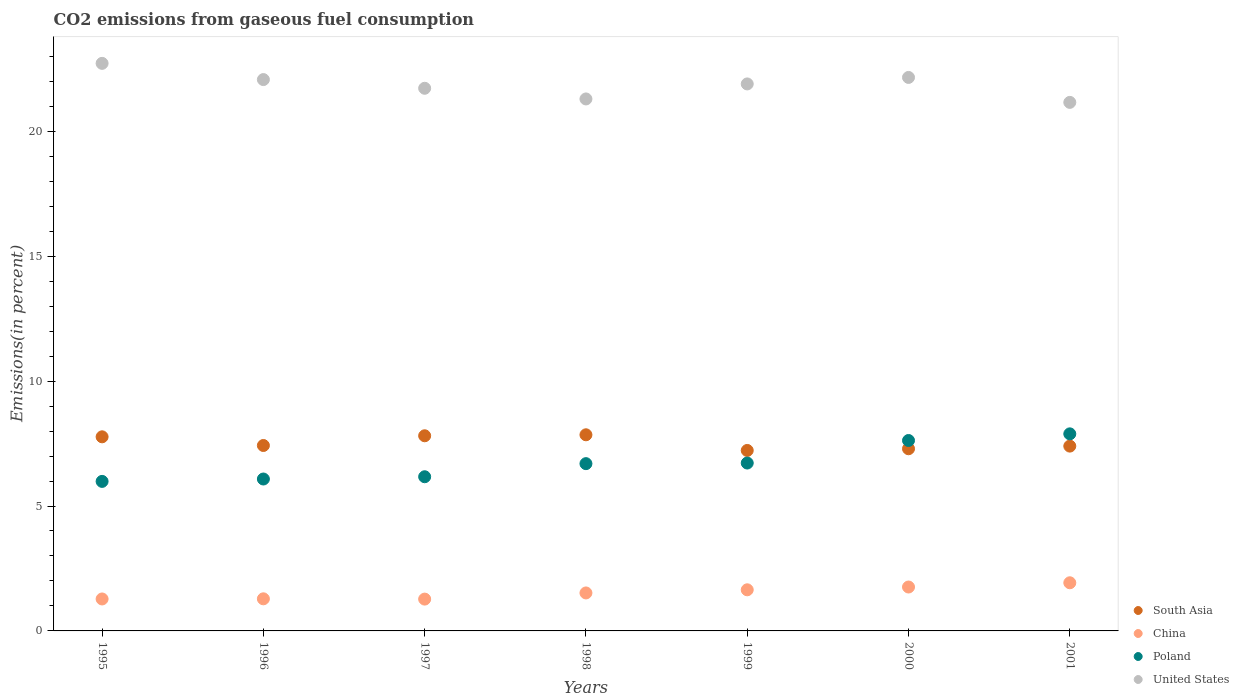How many different coloured dotlines are there?
Ensure brevity in your answer.  4. Is the number of dotlines equal to the number of legend labels?
Give a very brief answer. Yes. What is the total CO2 emitted in China in 1995?
Make the answer very short. 1.28. Across all years, what is the maximum total CO2 emitted in United States?
Give a very brief answer. 22.72. Across all years, what is the minimum total CO2 emitted in United States?
Ensure brevity in your answer.  21.16. What is the total total CO2 emitted in United States in the graph?
Your response must be concise. 153.01. What is the difference between the total CO2 emitted in China in 1999 and that in 2001?
Give a very brief answer. -0.28. What is the difference between the total CO2 emitted in South Asia in 1997 and the total CO2 emitted in China in 1996?
Offer a terse response. 6.53. What is the average total CO2 emitted in United States per year?
Your answer should be very brief. 21.86. In the year 1995, what is the difference between the total CO2 emitted in China and total CO2 emitted in South Asia?
Provide a succinct answer. -6.49. In how many years, is the total CO2 emitted in Poland greater than 20 %?
Ensure brevity in your answer.  0. What is the ratio of the total CO2 emitted in United States in 1997 to that in 1999?
Make the answer very short. 0.99. Is the total CO2 emitted in China in 1995 less than that in 1996?
Your answer should be very brief. Yes. What is the difference between the highest and the second highest total CO2 emitted in China?
Offer a terse response. 0.17. What is the difference between the highest and the lowest total CO2 emitted in Poland?
Ensure brevity in your answer.  1.9. Is the sum of the total CO2 emitted in Poland in 1996 and 1999 greater than the maximum total CO2 emitted in China across all years?
Offer a terse response. Yes. Is it the case that in every year, the sum of the total CO2 emitted in Poland and total CO2 emitted in United States  is greater than the sum of total CO2 emitted in South Asia and total CO2 emitted in China?
Your answer should be compact. Yes. Is it the case that in every year, the sum of the total CO2 emitted in South Asia and total CO2 emitted in United States  is greater than the total CO2 emitted in Poland?
Provide a short and direct response. Yes. Does the total CO2 emitted in Poland monotonically increase over the years?
Make the answer very short. Yes. Are the values on the major ticks of Y-axis written in scientific E-notation?
Your response must be concise. No. How are the legend labels stacked?
Your response must be concise. Vertical. What is the title of the graph?
Provide a succinct answer. CO2 emissions from gaseous fuel consumption. What is the label or title of the Y-axis?
Keep it short and to the point. Emissions(in percent). What is the Emissions(in percent) of South Asia in 1995?
Your response must be concise. 7.77. What is the Emissions(in percent) in China in 1995?
Your answer should be compact. 1.28. What is the Emissions(in percent) of Poland in 1995?
Make the answer very short. 5.99. What is the Emissions(in percent) in United States in 1995?
Give a very brief answer. 22.72. What is the Emissions(in percent) of South Asia in 1996?
Provide a short and direct response. 7.42. What is the Emissions(in percent) in China in 1996?
Your answer should be compact. 1.29. What is the Emissions(in percent) in Poland in 1996?
Offer a very short reply. 6.08. What is the Emissions(in percent) of United States in 1996?
Make the answer very short. 22.07. What is the Emissions(in percent) in South Asia in 1997?
Give a very brief answer. 7.81. What is the Emissions(in percent) in China in 1997?
Offer a very short reply. 1.27. What is the Emissions(in percent) of Poland in 1997?
Offer a very short reply. 6.17. What is the Emissions(in percent) of United States in 1997?
Keep it short and to the point. 21.72. What is the Emissions(in percent) of South Asia in 1998?
Give a very brief answer. 7.85. What is the Emissions(in percent) of China in 1998?
Your answer should be compact. 1.52. What is the Emissions(in percent) of Poland in 1998?
Your answer should be compact. 6.7. What is the Emissions(in percent) in United States in 1998?
Provide a succinct answer. 21.29. What is the Emissions(in percent) in South Asia in 1999?
Your answer should be compact. 7.22. What is the Emissions(in percent) of China in 1999?
Offer a terse response. 1.65. What is the Emissions(in percent) in Poland in 1999?
Make the answer very short. 6.72. What is the Emissions(in percent) in United States in 1999?
Your answer should be compact. 21.9. What is the Emissions(in percent) of South Asia in 2000?
Provide a short and direct response. 7.29. What is the Emissions(in percent) in China in 2000?
Your answer should be very brief. 1.76. What is the Emissions(in percent) in Poland in 2000?
Your answer should be compact. 7.62. What is the Emissions(in percent) of United States in 2000?
Ensure brevity in your answer.  22.16. What is the Emissions(in percent) of South Asia in 2001?
Your answer should be very brief. 7.4. What is the Emissions(in percent) in China in 2001?
Make the answer very short. 1.93. What is the Emissions(in percent) of Poland in 2001?
Keep it short and to the point. 7.89. What is the Emissions(in percent) in United States in 2001?
Your response must be concise. 21.16. Across all years, what is the maximum Emissions(in percent) in South Asia?
Provide a short and direct response. 7.85. Across all years, what is the maximum Emissions(in percent) in China?
Provide a succinct answer. 1.93. Across all years, what is the maximum Emissions(in percent) in Poland?
Provide a short and direct response. 7.89. Across all years, what is the maximum Emissions(in percent) in United States?
Provide a short and direct response. 22.72. Across all years, what is the minimum Emissions(in percent) of South Asia?
Give a very brief answer. 7.22. Across all years, what is the minimum Emissions(in percent) of China?
Make the answer very short. 1.27. Across all years, what is the minimum Emissions(in percent) of Poland?
Provide a succinct answer. 5.99. Across all years, what is the minimum Emissions(in percent) in United States?
Your answer should be compact. 21.16. What is the total Emissions(in percent) in South Asia in the graph?
Ensure brevity in your answer.  52.77. What is the total Emissions(in percent) in China in the graph?
Keep it short and to the point. 10.69. What is the total Emissions(in percent) in Poland in the graph?
Provide a succinct answer. 47.16. What is the total Emissions(in percent) in United States in the graph?
Offer a very short reply. 153.01. What is the difference between the Emissions(in percent) in South Asia in 1995 and that in 1996?
Offer a very short reply. 0.35. What is the difference between the Emissions(in percent) of China in 1995 and that in 1996?
Your response must be concise. -0.01. What is the difference between the Emissions(in percent) of Poland in 1995 and that in 1996?
Your answer should be compact. -0.1. What is the difference between the Emissions(in percent) of United States in 1995 and that in 1996?
Offer a terse response. 0.65. What is the difference between the Emissions(in percent) in South Asia in 1995 and that in 1997?
Offer a very short reply. -0.04. What is the difference between the Emissions(in percent) in China in 1995 and that in 1997?
Give a very brief answer. 0.01. What is the difference between the Emissions(in percent) in Poland in 1995 and that in 1997?
Your response must be concise. -0.19. What is the difference between the Emissions(in percent) of South Asia in 1995 and that in 1998?
Ensure brevity in your answer.  -0.08. What is the difference between the Emissions(in percent) in China in 1995 and that in 1998?
Your answer should be very brief. -0.24. What is the difference between the Emissions(in percent) of Poland in 1995 and that in 1998?
Your answer should be very brief. -0.71. What is the difference between the Emissions(in percent) of United States in 1995 and that in 1998?
Ensure brevity in your answer.  1.42. What is the difference between the Emissions(in percent) of South Asia in 1995 and that in 1999?
Provide a short and direct response. 0.55. What is the difference between the Emissions(in percent) of China in 1995 and that in 1999?
Offer a terse response. -0.37. What is the difference between the Emissions(in percent) of Poland in 1995 and that in 1999?
Your response must be concise. -0.73. What is the difference between the Emissions(in percent) of United States in 1995 and that in 1999?
Offer a very short reply. 0.82. What is the difference between the Emissions(in percent) in South Asia in 1995 and that in 2000?
Your answer should be very brief. 0.48. What is the difference between the Emissions(in percent) in China in 1995 and that in 2000?
Make the answer very short. -0.48. What is the difference between the Emissions(in percent) of Poland in 1995 and that in 2000?
Ensure brevity in your answer.  -1.64. What is the difference between the Emissions(in percent) of United States in 1995 and that in 2000?
Keep it short and to the point. 0.56. What is the difference between the Emissions(in percent) in South Asia in 1995 and that in 2001?
Offer a very short reply. 0.37. What is the difference between the Emissions(in percent) of China in 1995 and that in 2001?
Your answer should be very brief. -0.65. What is the difference between the Emissions(in percent) in Poland in 1995 and that in 2001?
Your response must be concise. -1.9. What is the difference between the Emissions(in percent) in United States in 1995 and that in 2001?
Your response must be concise. 1.56. What is the difference between the Emissions(in percent) in South Asia in 1996 and that in 1997?
Provide a succinct answer. -0.39. What is the difference between the Emissions(in percent) in China in 1996 and that in 1997?
Your answer should be compact. 0.01. What is the difference between the Emissions(in percent) of Poland in 1996 and that in 1997?
Your response must be concise. -0.09. What is the difference between the Emissions(in percent) in United States in 1996 and that in 1997?
Keep it short and to the point. 0.35. What is the difference between the Emissions(in percent) of South Asia in 1996 and that in 1998?
Make the answer very short. -0.43. What is the difference between the Emissions(in percent) of China in 1996 and that in 1998?
Keep it short and to the point. -0.24. What is the difference between the Emissions(in percent) in Poland in 1996 and that in 1998?
Your answer should be very brief. -0.61. What is the difference between the Emissions(in percent) of United States in 1996 and that in 1998?
Your answer should be compact. 0.78. What is the difference between the Emissions(in percent) in South Asia in 1996 and that in 1999?
Your response must be concise. 0.2. What is the difference between the Emissions(in percent) of China in 1996 and that in 1999?
Give a very brief answer. -0.36. What is the difference between the Emissions(in percent) in Poland in 1996 and that in 1999?
Keep it short and to the point. -0.64. What is the difference between the Emissions(in percent) of United States in 1996 and that in 1999?
Give a very brief answer. 0.17. What is the difference between the Emissions(in percent) of South Asia in 1996 and that in 2000?
Ensure brevity in your answer.  0.13. What is the difference between the Emissions(in percent) of China in 1996 and that in 2000?
Give a very brief answer. -0.47. What is the difference between the Emissions(in percent) in Poland in 1996 and that in 2000?
Make the answer very short. -1.54. What is the difference between the Emissions(in percent) of United States in 1996 and that in 2000?
Provide a succinct answer. -0.09. What is the difference between the Emissions(in percent) of South Asia in 1996 and that in 2001?
Provide a short and direct response. 0.02. What is the difference between the Emissions(in percent) of China in 1996 and that in 2001?
Your answer should be very brief. -0.64. What is the difference between the Emissions(in percent) of Poland in 1996 and that in 2001?
Your answer should be very brief. -1.81. What is the difference between the Emissions(in percent) of United States in 1996 and that in 2001?
Your answer should be compact. 0.91. What is the difference between the Emissions(in percent) in South Asia in 1997 and that in 1998?
Keep it short and to the point. -0.04. What is the difference between the Emissions(in percent) of China in 1997 and that in 1998?
Offer a very short reply. -0.25. What is the difference between the Emissions(in percent) of Poland in 1997 and that in 1998?
Your response must be concise. -0.52. What is the difference between the Emissions(in percent) in United States in 1997 and that in 1998?
Your answer should be compact. 0.43. What is the difference between the Emissions(in percent) of South Asia in 1997 and that in 1999?
Provide a succinct answer. 0.59. What is the difference between the Emissions(in percent) of China in 1997 and that in 1999?
Offer a terse response. -0.37. What is the difference between the Emissions(in percent) of Poland in 1997 and that in 1999?
Offer a very short reply. -0.55. What is the difference between the Emissions(in percent) in United States in 1997 and that in 1999?
Offer a very short reply. -0.17. What is the difference between the Emissions(in percent) in South Asia in 1997 and that in 2000?
Ensure brevity in your answer.  0.52. What is the difference between the Emissions(in percent) of China in 1997 and that in 2000?
Your answer should be very brief. -0.48. What is the difference between the Emissions(in percent) in Poland in 1997 and that in 2000?
Provide a succinct answer. -1.45. What is the difference between the Emissions(in percent) in United States in 1997 and that in 2000?
Make the answer very short. -0.43. What is the difference between the Emissions(in percent) of South Asia in 1997 and that in 2001?
Offer a very short reply. 0.41. What is the difference between the Emissions(in percent) in China in 1997 and that in 2001?
Your answer should be very brief. -0.65. What is the difference between the Emissions(in percent) in Poland in 1997 and that in 2001?
Provide a succinct answer. -1.72. What is the difference between the Emissions(in percent) of United States in 1997 and that in 2001?
Your response must be concise. 0.56. What is the difference between the Emissions(in percent) of South Asia in 1998 and that in 1999?
Your answer should be compact. 0.63. What is the difference between the Emissions(in percent) of China in 1998 and that in 1999?
Make the answer very short. -0.13. What is the difference between the Emissions(in percent) in Poland in 1998 and that in 1999?
Ensure brevity in your answer.  -0.02. What is the difference between the Emissions(in percent) in United States in 1998 and that in 1999?
Provide a succinct answer. -0.6. What is the difference between the Emissions(in percent) in South Asia in 1998 and that in 2000?
Provide a succinct answer. 0.56. What is the difference between the Emissions(in percent) in China in 1998 and that in 2000?
Your answer should be compact. -0.24. What is the difference between the Emissions(in percent) in Poland in 1998 and that in 2000?
Offer a terse response. -0.93. What is the difference between the Emissions(in percent) of United States in 1998 and that in 2000?
Keep it short and to the point. -0.86. What is the difference between the Emissions(in percent) in South Asia in 1998 and that in 2001?
Your answer should be very brief. 0.45. What is the difference between the Emissions(in percent) in China in 1998 and that in 2001?
Give a very brief answer. -0.41. What is the difference between the Emissions(in percent) of Poland in 1998 and that in 2001?
Ensure brevity in your answer.  -1.19. What is the difference between the Emissions(in percent) in United States in 1998 and that in 2001?
Make the answer very short. 0.14. What is the difference between the Emissions(in percent) of South Asia in 1999 and that in 2000?
Offer a very short reply. -0.07. What is the difference between the Emissions(in percent) in China in 1999 and that in 2000?
Ensure brevity in your answer.  -0.11. What is the difference between the Emissions(in percent) in Poland in 1999 and that in 2000?
Your answer should be compact. -0.9. What is the difference between the Emissions(in percent) in United States in 1999 and that in 2000?
Make the answer very short. -0.26. What is the difference between the Emissions(in percent) of South Asia in 1999 and that in 2001?
Ensure brevity in your answer.  -0.17. What is the difference between the Emissions(in percent) in China in 1999 and that in 2001?
Offer a terse response. -0.28. What is the difference between the Emissions(in percent) in Poland in 1999 and that in 2001?
Keep it short and to the point. -1.17. What is the difference between the Emissions(in percent) of United States in 1999 and that in 2001?
Offer a terse response. 0.74. What is the difference between the Emissions(in percent) of South Asia in 2000 and that in 2001?
Offer a terse response. -0.11. What is the difference between the Emissions(in percent) in China in 2000 and that in 2001?
Keep it short and to the point. -0.17. What is the difference between the Emissions(in percent) in Poland in 2000 and that in 2001?
Give a very brief answer. -0.27. What is the difference between the Emissions(in percent) of United States in 2000 and that in 2001?
Your response must be concise. 1. What is the difference between the Emissions(in percent) in South Asia in 1995 and the Emissions(in percent) in China in 1996?
Give a very brief answer. 6.48. What is the difference between the Emissions(in percent) of South Asia in 1995 and the Emissions(in percent) of Poland in 1996?
Offer a terse response. 1.69. What is the difference between the Emissions(in percent) in South Asia in 1995 and the Emissions(in percent) in United States in 1996?
Provide a succinct answer. -14.3. What is the difference between the Emissions(in percent) of China in 1995 and the Emissions(in percent) of Poland in 1996?
Provide a short and direct response. -4.8. What is the difference between the Emissions(in percent) in China in 1995 and the Emissions(in percent) in United States in 1996?
Your response must be concise. -20.79. What is the difference between the Emissions(in percent) in Poland in 1995 and the Emissions(in percent) in United States in 1996?
Your answer should be very brief. -16.08. What is the difference between the Emissions(in percent) of South Asia in 1995 and the Emissions(in percent) of China in 1997?
Your answer should be very brief. 6.5. What is the difference between the Emissions(in percent) in South Asia in 1995 and the Emissions(in percent) in Poland in 1997?
Keep it short and to the point. 1.6. What is the difference between the Emissions(in percent) in South Asia in 1995 and the Emissions(in percent) in United States in 1997?
Keep it short and to the point. -13.95. What is the difference between the Emissions(in percent) in China in 1995 and the Emissions(in percent) in Poland in 1997?
Your answer should be very brief. -4.89. What is the difference between the Emissions(in percent) of China in 1995 and the Emissions(in percent) of United States in 1997?
Provide a short and direct response. -20.44. What is the difference between the Emissions(in percent) of Poland in 1995 and the Emissions(in percent) of United States in 1997?
Your response must be concise. -15.74. What is the difference between the Emissions(in percent) of South Asia in 1995 and the Emissions(in percent) of China in 1998?
Provide a short and direct response. 6.25. What is the difference between the Emissions(in percent) in South Asia in 1995 and the Emissions(in percent) in Poland in 1998?
Provide a succinct answer. 1.07. What is the difference between the Emissions(in percent) of South Asia in 1995 and the Emissions(in percent) of United States in 1998?
Your answer should be compact. -13.52. What is the difference between the Emissions(in percent) of China in 1995 and the Emissions(in percent) of Poland in 1998?
Give a very brief answer. -5.42. What is the difference between the Emissions(in percent) in China in 1995 and the Emissions(in percent) in United States in 1998?
Provide a short and direct response. -20.02. What is the difference between the Emissions(in percent) in Poland in 1995 and the Emissions(in percent) in United States in 1998?
Your answer should be very brief. -15.31. What is the difference between the Emissions(in percent) of South Asia in 1995 and the Emissions(in percent) of China in 1999?
Keep it short and to the point. 6.12. What is the difference between the Emissions(in percent) in South Asia in 1995 and the Emissions(in percent) in Poland in 1999?
Give a very brief answer. 1.05. What is the difference between the Emissions(in percent) of South Asia in 1995 and the Emissions(in percent) of United States in 1999?
Offer a terse response. -14.13. What is the difference between the Emissions(in percent) in China in 1995 and the Emissions(in percent) in Poland in 1999?
Give a very brief answer. -5.44. What is the difference between the Emissions(in percent) of China in 1995 and the Emissions(in percent) of United States in 1999?
Offer a terse response. -20.62. What is the difference between the Emissions(in percent) in Poland in 1995 and the Emissions(in percent) in United States in 1999?
Your answer should be compact. -15.91. What is the difference between the Emissions(in percent) of South Asia in 1995 and the Emissions(in percent) of China in 2000?
Provide a succinct answer. 6.01. What is the difference between the Emissions(in percent) in South Asia in 1995 and the Emissions(in percent) in Poland in 2000?
Provide a succinct answer. 0.15. What is the difference between the Emissions(in percent) of South Asia in 1995 and the Emissions(in percent) of United States in 2000?
Offer a terse response. -14.39. What is the difference between the Emissions(in percent) in China in 1995 and the Emissions(in percent) in Poland in 2000?
Provide a short and direct response. -6.34. What is the difference between the Emissions(in percent) of China in 1995 and the Emissions(in percent) of United States in 2000?
Give a very brief answer. -20.88. What is the difference between the Emissions(in percent) in Poland in 1995 and the Emissions(in percent) in United States in 2000?
Your answer should be compact. -16.17. What is the difference between the Emissions(in percent) of South Asia in 1995 and the Emissions(in percent) of China in 2001?
Give a very brief answer. 5.84. What is the difference between the Emissions(in percent) of South Asia in 1995 and the Emissions(in percent) of Poland in 2001?
Give a very brief answer. -0.12. What is the difference between the Emissions(in percent) in South Asia in 1995 and the Emissions(in percent) in United States in 2001?
Your answer should be very brief. -13.39. What is the difference between the Emissions(in percent) in China in 1995 and the Emissions(in percent) in Poland in 2001?
Provide a short and direct response. -6.61. What is the difference between the Emissions(in percent) in China in 1995 and the Emissions(in percent) in United States in 2001?
Give a very brief answer. -19.88. What is the difference between the Emissions(in percent) of Poland in 1995 and the Emissions(in percent) of United States in 2001?
Provide a short and direct response. -15.17. What is the difference between the Emissions(in percent) of South Asia in 1996 and the Emissions(in percent) of China in 1997?
Offer a terse response. 6.15. What is the difference between the Emissions(in percent) of South Asia in 1996 and the Emissions(in percent) of Poland in 1997?
Provide a succinct answer. 1.25. What is the difference between the Emissions(in percent) in South Asia in 1996 and the Emissions(in percent) in United States in 1997?
Offer a terse response. -14.3. What is the difference between the Emissions(in percent) in China in 1996 and the Emissions(in percent) in Poland in 1997?
Your answer should be very brief. -4.89. What is the difference between the Emissions(in percent) of China in 1996 and the Emissions(in percent) of United States in 1997?
Make the answer very short. -20.44. What is the difference between the Emissions(in percent) of Poland in 1996 and the Emissions(in percent) of United States in 1997?
Give a very brief answer. -15.64. What is the difference between the Emissions(in percent) in South Asia in 1996 and the Emissions(in percent) in China in 1998?
Your answer should be very brief. 5.9. What is the difference between the Emissions(in percent) of South Asia in 1996 and the Emissions(in percent) of Poland in 1998?
Your answer should be compact. 0.73. What is the difference between the Emissions(in percent) of South Asia in 1996 and the Emissions(in percent) of United States in 1998?
Offer a terse response. -13.87. What is the difference between the Emissions(in percent) in China in 1996 and the Emissions(in percent) in Poland in 1998?
Keep it short and to the point. -5.41. What is the difference between the Emissions(in percent) in China in 1996 and the Emissions(in percent) in United States in 1998?
Your response must be concise. -20.01. What is the difference between the Emissions(in percent) of Poland in 1996 and the Emissions(in percent) of United States in 1998?
Give a very brief answer. -15.21. What is the difference between the Emissions(in percent) in South Asia in 1996 and the Emissions(in percent) in China in 1999?
Your response must be concise. 5.78. What is the difference between the Emissions(in percent) in South Asia in 1996 and the Emissions(in percent) in Poland in 1999?
Your response must be concise. 0.7. What is the difference between the Emissions(in percent) in South Asia in 1996 and the Emissions(in percent) in United States in 1999?
Keep it short and to the point. -14.47. What is the difference between the Emissions(in percent) of China in 1996 and the Emissions(in percent) of Poland in 1999?
Your answer should be compact. -5.44. What is the difference between the Emissions(in percent) in China in 1996 and the Emissions(in percent) in United States in 1999?
Keep it short and to the point. -20.61. What is the difference between the Emissions(in percent) of Poland in 1996 and the Emissions(in percent) of United States in 1999?
Provide a short and direct response. -15.81. What is the difference between the Emissions(in percent) in South Asia in 1996 and the Emissions(in percent) in China in 2000?
Your response must be concise. 5.66. What is the difference between the Emissions(in percent) in South Asia in 1996 and the Emissions(in percent) in Poland in 2000?
Make the answer very short. -0.2. What is the difference between the Emissions(in percent) in South Asia in 1996 and the Emissions(in percent) in United States in 2000?
Give a very brief answer. -14.73. What is the difference between the Emissions(in percent) in China in 1996 and the Emissions(in percent) in Poland in 2000?
Your answer should be compact. -6.34. What is the difference between the Emissions(in percent) in China in 1996 and the Emissions(in percent) in United States in 2000?
Keep it short and to the point. -20.87. What is the difference between the Emissions(in percent) of Poland in 1996 and the Emissions(in percent) of United States in 2000?
Offer a very short reply. -16.08. What is the difference between the Emissions(in percent) in South Asia in 1996 and the Emissions(in percent) in China in 2001?
Keep it short and to the point. 5.5. What is the difference between the Emissions(in percent) in South Asia in 1996 and the Emissions(in percent) in Poland in 2001?
Your answer should be very brief. -0.47. What is the difference between the Emissions(in percent) of South Asia in 1996 and the Emissions(in percent) of United States in 2001?
Your answer should be very brief. -13.73. What is the difference between the Emissions(in percent) in China in 1996 and the Emissions(in percent) in Poland in 2001?
Give a very brief answer. -6.6. What is the difference between the Emissions(in percent) in China in 1996 and the Emissions(in percent) in United States in 2001?
Your answer should be compact. -19.87. What is the difference between the Emissions(in percent) in Poland in 1996 and the Emissions(in percent) in United States in 2001?
Provide a short and direct response. -15.08. What is the difference between the Emissions(in percent) in South Asia in 1997 and the Emissions(in percent) in China in 1998?
Provide a short and direct response. 6.29. What is the difference between the Emissions(in percent) in South Asia in 1997 and the Emissions(in percent) in Poland in 1998?
Make the answer very short. 1.12. What is the difference between the Emissions(in percent) in South Asia in 1997 and the Emissions(in percent) in United States in 1998?
Your answer should be very brief. -13.48. What is the difference between the Emissions(in percent) in China in 1997 and the Emissions(in percent) in Poland in 1998?
Your answer should be very brief. -5.42. What is the difference between the Emissions(in percent) of China in 1997 and the Emissions(in percent) of United States in 1998?
Offer a terse response. -20.02. What is the difference between the Emissions(in percent) in Poland in 1997 and the Emissions(in percent) in United States in 1998?
Provide a short and direct response. -15.12. What is the difference between the Emissions(in percent) of South Asia in 1997 and the Emissions(in percent) of China in 1999?
Keep it short and to the point. 6.17. What is the difference between the Emissions(in percent) in South Asia in 1997 and the Emissions(in percent) in Poland in 1999?
Offer a terse response. 1.09. What is the difference between the Emissions(in percent) in South Asia in 1997 and the Emissions(in percent) in United States in 1999?
Keep it short and to the point. -14.08. What is the difference between the Emissions(in percent) of China in 1997 and the Emissions(in percent) of Poland in 1999?
Your answer should be very brief. -5.45. What is the difference between the Emissions(in percent) in China in 1997 and the Emissions(in percent) in United States in 1999?
Provide a short and direct response. -20.62. What is the difference between the Emissions(in percent) of Poland in 1997 and the Emissions(in percent) of United States in 1999?
Make the answer very short. -15.72. What is the difference between the Emissions(in percent) of South Asia in 1997 and the Emissions(in percent) of China in 2000?
Provide a succinct answer. 6.05. What is the difference between the Emissions(in percent) of South Asia in 1997 and the Emissions(in percent) of Poland in 2000?
Offer a very short reply. 0.19. What is the difference between the Emissions(in percent) in South Asia in 1997 and the Emissions(in percent) in United States in 2000?
Offer a terse response. -14.34. What is the difference between the Emissions(in percent) in China in 1997 and the Emissions(in percent) in Poland in 2000?
Offer a very short reply. -6.35. What is the difference between the Emissions(in percent) of China in 1997 and the Emissions(in percent) of United States in 2000?
Your answer should be very brief. -20.88. What is the difference between the Emissions(in percent) of Poland in 1997 and the Emissions(in percent) of United States in 2000?
Make the answer very short. -15.98. What is the difference between the Emissions(in percent) of South Asia in 1997 and the Emissions(in percent) of China in 2001?
Offer a very short reply. 5.88. What is the difference between the Emissions(in percent) of South Asia in 1997 and the Emissions(in percent) of Poland in 2001?
Ensure brevity in your answer.  -0.08. What is the difference between the Emissions(in percent) of South Asia in 1997 and the Emissions(in percent) of United States in 2001?
Provide a succinct answer. -13.35. What is the difference between the Emissions(in percent) in China in 1997 and the Emissions(in percent) in Poland in 2001?
Provide a short and direct response. -6.61. What is the difference between the Emissions(in percent) in China in 1997 and the Emissions(in percent) in United States in 2001?
Provide a short and direct response. -19.88. What is the difference between the Emissions(in percent) of Poland in 1997 and the Emissions(in percent) of United States in 2001?
Ensure brevity in your answer.  -14.99. What is the difference between the Emissions(in percent) of South Asia in 1998 and the Emissions(in percent) of China in 1999?
Give a very brief answer. 6.2. What is the difference between the Emissions(in percent) of South Asia in 1998 and the Emissions(in percent) of Poland in 1999?
Give a very brief answer. 1.13. What is the difference between the Emissions(in percent) of South Asia in 1998 and the Emissions(in percent) of United States in 1999?
Provide a short and direct response. -14.04. What is the difference between the Emissions(in percent) in China in 1998 and the Emissions(in percent) in Poland in 1999?
Offer a terse response. -5.2. What is the difference between the Emissions(in percent) in China in 1998 and the Emissions(in percent) in United States in 1999?
Give a very brief answer. -20.38. What is the difference between the Emissions(in percent) of Poland in 1998 and the Emissions(in percent) of United States in 1999?
Give a very brief answer. -15.2. What is the difference between the Emissions(in percent) of South Asia in 1998 and the Emissions(in percent) of China in 2000?
Provide a short and direct response. 6.09. What is the difference between the Emissions(in percent) of South Asia in 1998 and the Emissions(in percent) of Poland in 2000?
Your answer should be very brief. 0.23. What is the difference between the Emissions(in percent) in South Asia in 1998 and the Emissions(in percent) in United States in 2000?
Your answer should be very brief. -14.3. What is the difference between the Emissions(in percent) of China in 1998 and the Emissions(in percent) of Poland in 2000?
Ensure brevity in your answer.  -6.1. What is the difference between the Emissions(in percent) in China in 1998 and the Emissions(in percent) in United States in 2000?
Offer a terse response. -20.64. What is the difference between the Emissions(in percent) in Poland in 1998 and the Emissions(in percent) in United States in 2000?
Your answer should be compact. -15.46. What is the difference between the Emissions(in percent) in South Asia in 1998 and the Emissions(in percent) in China in 2001?
Provide a short and direct response. 5.92. What is the difference between the Emissions(in percent) of South Asia in 1998 and the Emissions(in percent) of Poland in 2001?
Give a very brief answer. -0.04. What is the difference between the Emissions(in percent) of South Asia in 1998 and the Emissions(in percent) of United States in 2001?
Your answer should be compact. -13.31. What is the difference between the Emissions(in percent) of China in 1998 and the Emissions(in percent) of Poland in 2001?
Offer a very short reply. -6.37. What is the difference between the Emissions(in percent) of China in 1998 and the Emissions(in percent) of United States in 2001?
Your answer should be very brief. -19.64. What is the difference between the Emissions(in percent) in Poland in 1998 and the Emissions(in percent) in United States in 2001?
Offer a terse response. -14.46. What is the difference between the Emissions(in percent) in South Asia in 1999 and the Emissions(in percent) in China in 2000?
Your answer should be compact. 5.47. What is the difference between the Emissions(in percent) of South Asia in 1999 and the Emissions(in percent) of Poland in 2000?
Your response must be concise. -0.4. What is the difference between the Emissions(in percent) of South Asia in 1999 and the Emissions(in percent) of United States in 2000?
Ensure brevity in your answer.  -14.93. What is the difference between the Emissions(in percent) of China in 1999 and the Emissions(in percent) of Poland in 2000?
Provide a short and direct response. -5.98. What is the difference between the Emissions(in percent) in China in 1999 and the Emissions(in percent) in United States in 2000?
Your answer should be compact. -20.51. What is the difference between the Emissions(in percent) of Poland in 1999 and the Emissions(in percent) of United States in 2000?
Your response must be concise. -15.44. What is the difference between the Emissions(in percent) of South Asia in 1999 and the Emissions(in percent) of China in 2001?
Provide a short and direct response. 5.3. What is the difference between the Emissions(in percent) of South Asia in 1999 and the Emissions(in percent) of Poland in 2001?
Your answer should be very brief. -0.66. What is the difference between the Emissions(in percent) in South Asia in 1999 and the Emissions(in percent) in United States in 2001?
Make the answer very short. -13.93. What is the difference between the Emissions(in percent) in China in 1999 and the Emissions(in percent) in Poland in 2001?
Your answer should be compact. -6.24. What is the difference between the Emissions(in percent) of China in 1999 and the Emissions(in percent) of United States in 2001?
Your response must be concise. -19.51. What is the difference between the Emissions(in percent) of Poland in 1999 and the Emissions(in percent) of United States in 2001?
Your answer should be compact. -14.44. What is the difference between the Emissions(in percent) of South Asia in 2000 and the Emissions(in percent) of China in 2001?
Ensure brevity in your answer.  5.36. What is the difference between the Emissions(in percent) in South Asia in 2000 and the Emissions(in percent) in Poland in 2001?
Your answer should be compact. -0.6. What is the difference between the Emissions(in percent) of South Asia in 2000 and the Emissions(in percent) of United States in 2001?
Give a very brief answer. -13.87. What is the difference between the Emissions(in percent) of China in 2000 and the Emissions(in percent) of Poland in 2001?
Provide a succinct answer. -6.13. What is the difference between the Emissions(in percent) in China in 2000 and the Emissions(in percent) in United States in 2001?
Offer a terse response. -19.4. What is the difference between the Emissions(in percent) of Poland in 2000 and the Emissions(in percent) of United States in 2001?
Your answer should be compact. -13.53. What is the average Emissions(in percent) in South Asia per year?
Provide a short and direct response. 7.54. What is the average Emissions(in percent) of China per year?
Make the answer very short. 1.53. What is the average Emissions(in percent) of Poland per year?
Your response must be concise. 6.74. What is the average Emissions(in percent) in United States per year?
Keep it short and to the point. 21.86. In the year 1995, what is the difference between the Emissions(in percent) of South Asia and Emissions(in percent) of China?
Ensure brevity in your answer.  6.49. In the year 1995, what is the difference between the Emissions(in percent) in South Asia and Emissions(in percent) in Poland?
Give a very brief answer. 1.78. In the year 1995, what is the difference between the Emissions(in percent) of South Asia and Emissions(in percent) of United States?
Make the answer very short. -14.95. In the year 1995, what is the difference between the Emissions(in percent) of China and Emissions(in percent) of Poland?
Keep it short and to the point. -4.71. In the year 1995, what is the difference between the Emissions(in percent) in China and Emissions(in percent) in United States?
Offer a very short reply. -21.44. In the year 1995, what is the difference between the Emissions(in percent) in Poland and Emissions(in percent) in United States?
Your response must be concise. -16.73. In the year 1996, what is the difference between the Emissions(in percent) of South Asia and Emissions(in percent) of China?
Keep it short and to the point. 6.14. In the year 1996, what is the difference between the Emissions(in percent) in South Asia and Emissions(in percent) in Poland?
Offer a very short reply. 1.34. In the year 1996, what is the difference between the Emissions(in percent) of South Asia and Emissions(in percent) of United States?
Your answer should be compact. -14.65. In the year 1996, what is the difference between the Emissions(in percent) of China and Emissions(in percent) of Poland?
Your answer should be compact. -4.8. In the year 1996, what is the difference between the Emissions(in percent) in China and Emissions(in percent) in United States?
Give a very brief answer. -20.78. In the year 1996, what is the difference between the Emissions(in percent) of Poland and Emissions(in percent) of United States?
Provide a succinct answer. -15.99. In the year 1997, what is the difference between the Emissions(in percent) of South Asia and Emissions(in percent) of China?
Give a very brief answer. 6.54. In the year 1997, what is the difference between the Emissions(in percent) in South Asia and Emissions(in percent) in Poland?
Make the answer very short. 1.64. In the year 1997, what is the difference between the Emissions(in percent) in South Asia and Emissions(in percent) in United States?
Your answer should be very brief. -13.91. In the year 1997, what is the difference between the Emissions(in percent) of China and Emissions(in percent) of Poland?
Ensure brevity in your answer.  -4.9. In the year 1997, what is the difference between the Emissions(in percent) in China and Emissions(in percent) in United States?
Offer a very short reply. -20.45. In the year 1997, what is the difference between the Emissions(in percent) of Poland and Emissions(in percent) of United States?
Give a very brief answer. -15.55. In the year 1998, what is the difference between the Emissions(in percent) of South Asia and Emissions(in percent) of China?
Provide a short and direct response. 6.33. In the year 1998, what is the difference between the Emissions(in percent) of South Asia and Emissions(in percent) of Poland?
Ensure brevity in your answer.  1.16. In the year 1998, what is the difference between the Emissions(in percent) of South Asia and Emissions(in percent) of United States?
Offer a very short reply. -13.44. In the year 1998, what is the difference between the Emissions(in percent) in China and Emissions(in percent) in Poland?
Keep it short and to the point. -5.18. In the year 1998, what is the difference between the Emissions(in percent) of China and Emissions(in percent) of United States?
Provide a succinct answer. -19.77. In the year 1998, what is the difference between the Emissions(in percent) in Poland and Emissions(in percent) in United States?
Provide a short and direct response. -14.6. In the year 1999, what is the difference between the Emissions(in percent) in South Asia and Emissions(in percent) in China?
Offer a very short reply. 5.58. In the year 1999, what is the difference between the Emissions(in percent) of South Asia and Emissions(in percent) of Poland?
Make the answer very short. 0.5. In the year 1999, what is the difference between the Emissions(in percent) in South Asia and Emissions(in percent) in United States?
Offer a very short reply. -14.67. In the year 1999, what is the difference between the Emissions(in percent) of China and Emissions(in percent) of Poland?
Your answer should be compact. -5.07. In the year 1999, what is the difference between the Emissions(in percent) of China and Emissions(in percent) of United States?
Provide a short and direct response. -20.25. In the year 1999, what is the difference between the Emissions(in percent) in Poland and Emissions(in percent) in United States?
Provide a succinct answer. -15.18. In the year 2000, what is the difference between the Emissions(in percent) of South Asia and Emissions(in percent) of China?
Offer a very short reply. 5.53. In the year 2000, what is the difference between the Emissions(in percent) in South Asia and Emissions(in percent) in Poland?
Your answer should be very brief. -0.33. In the year 2000, what is the difference between the Emissions(in percent) of South Asia and Emissions(in percent) of United States?
Make the answer very short. -14.86. In the year 2000, what is the difference between the Emissions(in percent) in China and Emissions(in percent) in Poland?
Ensure brevity in your answer.  -5.87. In the year 2000, what is the difference between the Emissions(in percent) in China and Emissions(in percent) in United States?
Offer a very short reply. -20.4. In the year 2000, what is the difference between the Emissions(in percent) in Poland and Emissions(in percent) in United States?
Offer a very short reply. -14.53. In the year 2001, what is the difference between the Emissions(in percent) in South Asia and Emissions(in percent) in China?
Ensure brevity in your answer.  5.47. In the year 2001, what is the difference between the Emissions(in percent) in South Asia and Emissions(in percent) in Poland?
Give a very brief answer. -0.49. In the year 2001, what is the difference between the Emissions(in percent) of South Asia and Emissions(in percent) of United States?
Your answer should be very brief. -13.76. In the year 2001, what is the difference between the Emissions(in percent) in China and Emissions(in percent) in Poland?
Give a very brief answer. -5.96. In the year 2001, what is the difference between the Emissions(in percent) in China and Emissions(in percent) in United States?
Give a very brief answer. -19.23. In the year 2001, what is the difference between the Emissions(in percent) of Poland and Emissions(in percent) of United States?
Your answer should be very brief. -13.27. What is the ratio of the Emissions(in percent) of South Asia in 1995 to that in 1996?
Offer a terse response. 1.05. What is the ratio of the Emissions(in percent) in Poland in 1995 to that in 1996?
Your answer should be compact. 0.98. What is the ratio of the Emissions(in percent) of United States in 1995 to that in 1996?
Your answer should be compact. 1.03. What is the ratio of the Emissions(in percent) in South Asia in 1995 to that in 1997?
Give a very brief answer. 0.99. What is the ratio of the Emissions(in percent) of China in 1995 to that in 1997?
Keep it short and to the point. 1. What is the ratio of the Emissions(in percent) in Poland in 1995 to that in 1997?
Your answer should be very brief. 0.97. What is the ratio of the Emissions(in percent) of United States in 1995 to that in 1997?
Give a very brief answer. 1.05. What is the ratio of the Emissions(in percent) of China in 1995 to that in 1998?
Give a very brief answer. 0.84. What is the ratio of the Emissions(in percent) in Poland in 1995 to that in 1998?
Your answer should be very brief. 0.89. What is the ratio of the Emissions(in percent) of United States in 1995 to that in 1998?
Provide a short and direct response. 1.07. What is the ratio of the Emissions(in percent) of South Asia in 1995 to that in 1999?
Your answer should be very brief. 1.08. What is the ratio of the Emissions(in percent) in China in 1995 to that in 1999?
Give a very brief answer. 0.78. What is the ratio of the Emissions(in percent) of Poland in 1995 to that in 1999?
Your answer should be compact. 0.89. What is the ratio of the Emissions(in percent) in United States in 1995 to that in 1999?
Provide a succinct answer. 1.04. What is the ratio of the Emissions(in percent) in South Asia in 1995 to that in 2000?
Your answer should be compact. 1.07. What is the ratio of the Emissions(in percent) in China in 1995 to that in 2000?
Keep it short and to the point. 0.73. What is the ratio of the Emissions(in percent) in Poland in 1995 to that in 2000?
Offer a terse response. 0.79. What is the ratio of the Emissions(in percent) in United States in 1995 to that in 2000?
Keep it short and to the point. 1.03. What is the ratio of the Emissions(in percent) in South Asia in 1995 to that in 2001?
Offer a very short reply. 1.05. What is the ratio of the Emissions(in percent) of China in 1995 to that in 2001?
Ensure brevity in your answer.  0.66. What is the ratio of the Emissions(in percent) of Poland in 1995 to that in 2001?
Provide a succinct answer. 0.76. What is the ratio of the Emissions(in percent) of United States in 1995 to that in 2001?
Ensure brevity in your answer.  1.07. What is the ratio of the Emissions(in percent) of South Asia in 1996 to that in 1997?
Provide a short and direct response. 0.95. What is the ratio of the Emissions(in percent) of China in 1996 to that in 1997?
Give a very brief answer. 1.01. What is the ratio of the Emissions(in percent) of South Asia in 1996 to that in 1998?
Provide a short and direct response. 0.95. What is the ratio of the Emissions(in percent) in China in 1996 to that in 1998?
Provide a short and direct response. 0.85. What is the ratio of the Emissions(in percent) of Poland in 1996 to that in 1998?
Provide a short and direct response. 0.91. What is the ratio of the Emissions(in percent) of United States in 1996 to that in 1998?
Keep it short and to the point. 1.04. What is the ratio of the Emissions(in percent) in South Asia in 1996 to that in 1999?
Your response must be concise. 1.03. What is the ratio of the Emissions(in percent) of China in 1996 to that in 1999?
Keep it short and to the point. 0.78. What is the ratio of the Emissions(in percent) in Poland in 1996 to that in 1999?
Give a very brief answer. 0.9. What is the ratio of the Emissions(in percent) of United States in 1996 to that in 1999?
Provide a succinct answer. 1.01. What is the ratio of the Emissions(in percent) of South Asia in 1996 to that in 2000?
Provide a short and direct response. 1.02. What is the ratio of the Emissions(in percent) of China in 1996 to that in 2000?
Offer a terse response. 0.73. What is the ratio of the Emissions(in percent) in Poland in 1996 to that in 2000?
Give a very brief answer. 0.8. What is the ratio of the Emissions(in percent) in United States in 1996 to that in 2000?
Give a very brief answer. 1. What is the ratio of the Emissions(in percent) in South Asia in 1996 to that in 2001?
Offer a terse response. 1. What is the ratio of the Emissions(in percent) in China in 1996 to that in 2001?
Your answer should be compact. 0.67. What is the ratio of the Emissions(in percent) in Poland in 1996 to that in 2001?
Give a very brief answer. 0.77. What is the ratio of the Emissions(in percent) of United States in 1996 to that in 2001?
Ensure brevity in your answer.  1.04. What is the ratio of the Emissions(in percent) in South Asia in 1997 to that in 1998?
Your answer should be compact. 0.99. What is the ratio of the Emissions(in percent) of China in 1997 to that in 1998?
Keep it short and to the point. 0.84. What is the ratio of the Emissions(in percent) in Poland in 1997 to that in 1998?
Provide a short and direct response. 0.92. What is the ratio of the Emissions(in percent) in United States in 1997 to that in 1998?
Provide a succinct answer. 1.02. What is the ratio of the Emissions(in percent) in South Asia in 1997 to that in 1999?
Offer a very short reply. 1.08. What is the ratio of the Emissions(in percent) in China in 1997 to that in 1999?
Make the answer very short. 0.77. What is the ratio of the Emissions(in percent) in Poland in 1997 to that in 1999?
Offer a terse response. 0.92. What is the ratio of the Emissions(in percent) in South Asia in 1997 to that in 2000?
Keep it short and to the point. 1.07. What is the ratio of the Emissions(in percent) of China in 1997 to that in 2000?
Offer a very short reply. 0.72. What is the ratio of the Emissions(in percent) in Poland in 1997 to that in 2000?
Ensure brevity in your answer.  0.81. What is the ratio of the Emissions(in percent) in United States in 1997 to that in 2000?
Keep it short and to the point. 0.98. What is the ratio of the Emissions(in percent) of South Asia in 1997 to that in 2001?
Offer a terse response. 1.06. What is the ratio of the Emissions(in percent) in China in 1997 to that in 2001?
Ensure brevity in your answer.  0.66. What is the ratio of the Emissions(in percent) of Poland in 1997 to that in 2001?
Your response must be concise. 0.78. What is the ratio of the Emissions(in percent) in United States in 1997 to that in 2001?
Your answer should be very brief. 1.03. What is the ratio of the Emissions(in percent) of South Asia in 1998 to that in 1999?
Make the answer very short. 1.09. What is the ratio of the Emissions(in percent) of China in 1998 to that in 1999?
Offer a very short reply. 0.92. What is the ratio of the Emissions(in percent) in United States in 1998 to that in 1999?
Your response must be concise. 0.97. What is the ratio of the Emissions(in percent) in South Asia in 1998 to that in 2000?
Your answer should be compact. 1.08. What is the ratio of the Emissions(in percent) in China in 1998 to that in 2000?
Your response must be concise. 0.87. What is the ratio of the Emissions(in percent) in Poland in 1998 to that in 2000?
Keep it short and to the point. 0.88. What is the ratio of the Emissions(in percent) in United States in 1998 to that in 2000?
Ensure brevity in your answer.  0.96. What is the ratio of the Emissions(in percent) of South Asia in 1998 to that in 2001?
Keep it short and to the point. 1.06. What is the ratio of the Emissions(in percent) in China in 1998 to that in 2001?
Ensure brevity in your answer.  0.79. What is the ratio of the Emissions(in percent) in Poland in 1998 to that in 2001?
Provide a short and direct response. 0.85. What is the ratio of the Emissions(in percent) of United States in 1998 to that in 2001?
Offer a terse response. 1.01. What is the ratio of the Emissions(in percent) of China in 1999 to that in 2000?
Your answer should be very brief. 0.94. What is the ratio of the Emissions(in percent) in Poland in 1999 to that in 2000?
Ensure brevity in your answer.  0.88. What is the ratio of the Emissions(in percent) in United States in 1999 to that in 2000?
Ensure brevity in your answer.  0.99. What is the ratio of the Emissions(in percent) of South Asia in 1999 to that in 2001?
Your answer should be very brief. 0.98. What is the ratio of the Emissions(in percent) of China in 1999 to that in 2001?
Offer a very short reply. 0.85. What is the ratio of the Emissions(in percent) of Poland in 1999 to that in 2001?
Your response must be concise. 0.85. What is the ratio of the Emissions(in percent) of United States in 1999 to that in 2001?
Offer a very short reply. 1.03. What is the ratio of the Emissions(in percent) of South Asia in 2000 to that in 2001?
Make the answer very short. 0.99. What is the ratio of the Emissions(in percent) in China in 2000 to that in 2001?
Your response must be concise. 0.91. What is the ratio of the Emissions(in percent) of Poland in 2000 to that in 2001?
Offer a very short reply. 0.97. What is the ratio of the Emissions(in percent) of United States in 2000 to that in 2001?
Give a very brief answer. 1.05. What is the difference between the highest and the second highest Emissions(in percent) of South Asia?
Your response must be concise. 0.04. What is the difference between the highest and the second highest Emissions(in percent) in China?
Offer a very short reply. 0.17. What is the difference between the highest and the second highest Emissions(in percent) of Poland?
Offer a very short reply. 0.27. What is the difference between the highest and the second highest Emissions(in percent) in United States?
Make the answer very short. 0.56. What is the difference between the highest and the lowest Emissions(in percent) in South Asia?
Your response must be concise. 0.63. What is the difference between the highest and the lowest Emissions(in percent) in China?
Keep it short and to the point. 0.65. What is the difference between the highest and the lowest Emissions(in percent) in Poland?
Your answer should be very brief. 1.9. What is the difference between the highest and the lowest Emissions(in percent) of United States?
Your response must be concise. 1.56. 